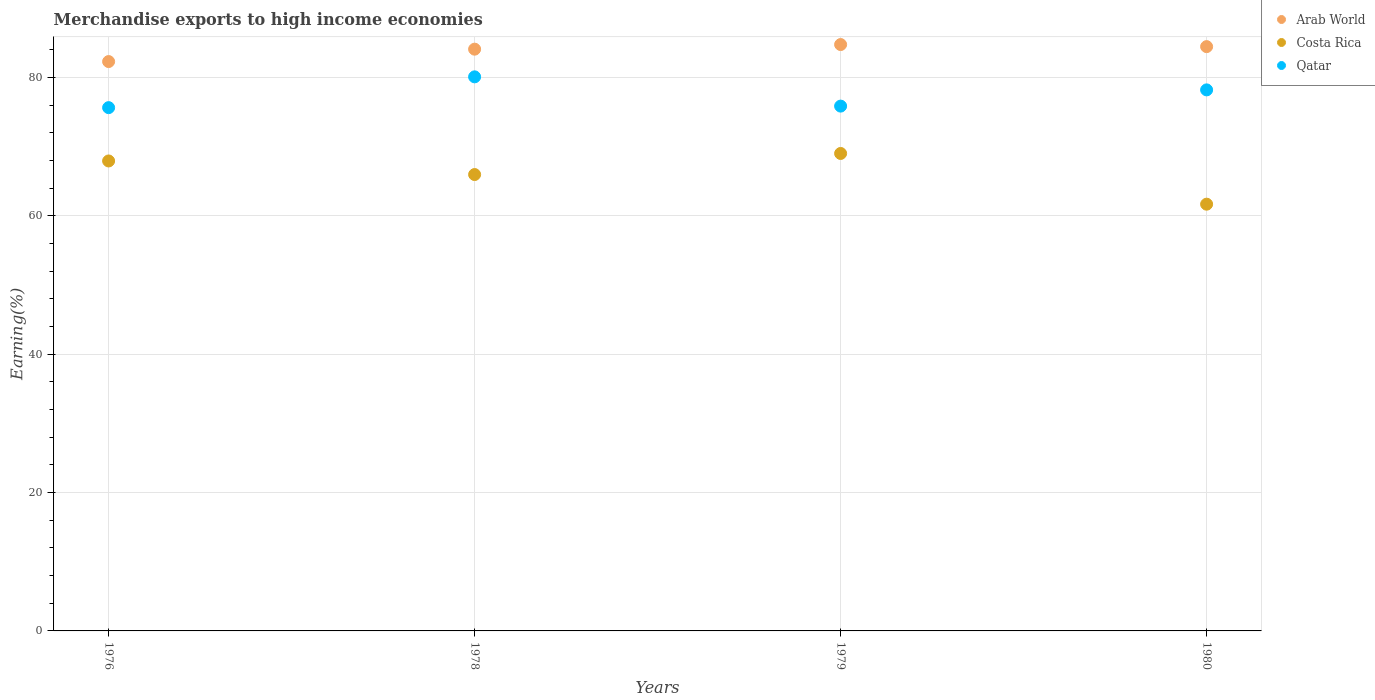What is the percentage of amount earned from merchandise exports in Qatar in 1978?
Ensure brevity in your answer.  80.09. Across all years, what is the maximum percentage of amount earned from merchandise exports in Arab World?
Your answer should be compact. 84.76. Across all years, what is the minimum percentage of amount earned from merchandise exports in Qatar?
Ensure brevity in your answer.  75.64. In which year was the percentage of amount earned from merchandise exports in Qatar maximum?
Your answer should be very brief. 1978. In which year was the percentage of amount earned from merchandise exports in Qatar minimum?
Give a very brief answer. 1976. What is the total percentage of amount earned from merchandise exports in Arab World in the graph?
Your answer should be compact. 335.62. What is the difference between the percentage of amount earned from merchandise exports in Arab World in 1978 and that in 1980?
Ensure brevity in your answer.  -0.37. What is the difference between the percentage of amount earned from merchandise exports in Costa Rica in 1978 and the percentage of amount earned from merchandise exports in Qatar in 1980?
Offer a very short reply. -12.24. What is the average percentage of amount earned from merchandise exports in Costa Rica per year?
Provide a succinct answer. 66.15. In the year 1979, what is the difference between the percentage of amount earned from merchandise exports in Costa Rica and percentage of amount earned from merchandise exports in Arab World?
Give a very brief answer. -15.74. What is the ratio of the percentage of amount earned from merchandise exports in Qatar in 1978 to that in 1979?
Offer a very short reply. 1.06. What is the difference between the highest and the second highest percentage of amount earned from merchandise exports in Qatar?
Offer a terse response. 1.89. What is the difference between the highest and the lowest percentage of amount earned from merchandise exports in Costa Rica?
Your response must be concise. 7.33. Is the percentage of amount earned from merchandise exports in Qatar strictly greater than the percentage of amount earned from merchandise exports in Arab World over the years?
Ensure brevity in your answer.  No. How many years are there in the graph?
Your answer should be compact. 4. Are the values on the major ticks of Y-axis written in scientific E-notation?
Ensure brevity in your answer.  No. Where does the legend appear in the graph?
Provide a succinct answer. Top right. What is the title of the graph?
Keep it short and to the point. Merchandise exports to high income economies. Does "Ireland" appear as one of the legend labels in the graph?
Provide a succinct answer. No. What is the label or title of the X-axis?
Your answer should be very brief. Years. What is the label or title of the Y-axis?
Your answer should be compact. Earning(%). What is the Earning(%) in Arab World in 1976?
Give a very brief answer. 82.3. What is the Earning(%) of Costa Rica in 1976?
Offer a very short reply. 67.94. What is the Earning(%) of Qatar in 1976?
Offer a very short reply. 75.64. What is the Earning(%) of Arab World in 1978?
Keep it short and to the point. 84.1. What is the Earning(%) of Costa Rica in 1978?
Your answer should be very brief. 65.97. What is the Earning(%) of Qatar in 1978?
Offer a terse response. 80.09. What is the Earning(%) of Arab World in 1979?
Your answer should be very brief. 84.76. What is the Earning(%) of Costa Rica in 1979?
Offer a terse response. 69.02. What is the Earning(%) in Qatar in 1979?
Make the answer very short. 75.86. What is the Earning(%) in Arab World in 1980?
Ensure brevity in your answer.  84.46. What is the Earning(%) in Costa Rica in 1980?
Make the answer very short. 61.69. What is the Earning(%) of Qatar in 1980?
Your answer should be very brief. 78.21. Across all years, what is the maximum Earning(%) of Arab World?
Give a very brief answer. 84.76. Across all years, what is the maximum Earning(%) of Costa Rica?
Offer a terse response. 69.02. Across all years, what is the maximum Earning(%) of Qatar?
Keep it short and to the point. 80.09. Across all years, what is the minimum Earning(%) in Arab World?
Your response must be concise. 82.3. Across all years, what is the minimum Earning(%) of Costa Rica?
Make the answer very short. 61.69. Across all years, what is the minimum Earning(%) of Qatar?
Ensure brevity in your answer.  75.64. What is the total Earning(%) of Arab World in the graph?
Provide a short and direct response. 335.62. What is the total Earning(%) in Costa Rica in the graph?
Provide a succinct answer. 264.61. What is the total Earning(%) in Qatar in the graph?
Offer a very short reply. 309.81. What is the difference between the Earning(%) of Arab World in 1976 and that in 1978?
Your response must be concise. -1.79. What is the difference between the Earning(%) of Costa Rica in 1976 and that in 1978?
Provide a short and direct response. 1.96. What is the difference between the Earning(%) of Qatar in 1976 and that in 1978?
Your response must be concise. -4.45. What is the difference between the Earning(%) of Arab World in 1976 and that in 1979?
Your response must be concise. -2.46. What is the difference between the Earning(%) in Costa Rica in 1976 and that in 1979?
Your answer should be compact. -1.08. What is the difference between the Earning(%) of Qatar in 1976 and that in 1979?
Keep it short and to the point. -0.22. What is the difference between the Earning(%) in Arab World in 1976 and that in 1980?
Offer a terse response. -2.16. What is the difference between the Earning(%) of Costa Rica in 1976 and that in 1980?
Make the answer very short. 6.25. What is the difference between the Earning(%) of Qatar in 1976 and that in 1980?
Offer a very short reply. -2.57. What is the difference between the Earning(%) of Arab World in 1978 and that in 1979?
Your answer should be very brief. -0.67. What is the difference between the Earning(%) of Costa Rica in 1978 and that in 1979?
Keep it short and to the point. -3.05. What is the difference between the Earning(%) of Qatar in 1978 and that in 1979?
Ensure brevity in your answer.  4.23. What is the difference between the Earning(%) of Arab World in 1978 and that in 1980?
Offer a very short reply. -0.37. What is the difference between the Earning(%) of Costa Rica in 1978 and that in 1980?
Provide a short and direct response. 4.28. What is the difference between the Earning(%) of Qatar in 1978 and that in 1980?
Keep it short and to the point. 1.89. What is the difference between the Earning(%) of Arab World in 1979 and that in 1980?
Your response must be concise. 0.3. What is the difference between the Earning(%) in Costa Rica in 1979 and that in 1980?
Your answer should be compact. 7.33. What is the difference between the Earning(%) of Qatar in 1979 and that in 1980?
Offer a terse response. -2.35. What is the difference between the Earning(%) of Arab World in 1976 and the Earning(%) of Costa Rica in 1978?
Offer a very short reply. 16.33. What is the difference between the Earning(%) in Arab World in 1976 and the Earning(%) in Qatar in 1978?
Give a very brief answer. 2.21. What is the difference between the Earning(%) in Costa Rica in 1976 and the Earning(%) in Qatar in 1978?
Make the answer very short. -12.16. What is the difference between the Earning(%) in Arab World in 1976 and the Earning(%) in Costa Rica in 1979?
Your answer should be compact. 13.28. What is the difference between the Earning(%) of Arab World in 1976 and the Earning(%) of Qatar in 1979?
Give a very brief answer. 6.44. What is the difference between the Earning(%) of Costa Rica in 1976 and the Earning(%) of Qatar in 1979?
Your answer should be very brief. -7.93. What is the difference between the Earning(%) of Arab World in 1976 and the Earning(%) of Costa Rica in 1980?
Offer a terse response. 20.62. What is the difference between the Earning(%) in Arab World in 1976 and the Earning(%) in Qatar in 1980?
Provide a short and direct response. 4.09. What is the difference between the Earning(%) in Costa Rica in 1976 and the Earning(%) in Qatar in 1980?
Your answer should be compact. -10.27. What is the difference between the Earning(%) of Arab World in 1978 and the Earning(%) of Costa Rica in 1979?
Provide a short and direct response. 15.08. What is the difference between the Earning(%) of Arab World in 1978 and the Earning(%) of Qatar in 1979?
Offer a very short reply. 8.23. What is the difference between the Earning(%) of Costa Rica in 1978 and the Earning(%) of Qatar in 1979?
Your answer should be compact. -9.89. What is the difference between the Earning(%) in Arab World in 1978 and the Earning(%) in Costa Rica in 1980?
Give a very brief answer. 22.41. What is the difference between the Earning(%) in Arab World in 1978 and the Earning(%) in Qatar in 1980?
Offer a very short reply. 5.89. What is the difference between the Earning(%) in Costa Rica in 1978 and the Earning(%) in Qatar in 1980?
Offer a terse response. -12.24. What is the difference between the Earning(%) in Arab World in 1979 and the Earning(%) in Costa Rica in 1980?
Offer a very short reply. 23.07. What is the difference between the Earning(%) in Arab World in 1979 and the Earning(%) in Qatar in 1980?
Ensure brevity in your answer.  6.55. What is the difference between the Earning(%) in Costa Rica in 1979 and the Earning(%) in Qatar in 1980?
Offer a terse response. -9.19. What is the average Earning(%) in Arab World per year?
Make the answer very short. 83.91. What is the average Earning(%) of Costa Rica per year?
Your response must be concise. 66.15. What is the average Earning(%) of Qatar per year?
Provide a succinct answer. 77.45. In the year 1976, what is the difference between the Earning(%) of Arab World and Earning(%) of Costa Rica?
Offer a terse response. 14.37. In the year 1976, what is the difference between the Earning(%) of Arab World and Earning(%) of Qatar?
Ensure brevity in your answer.  6.66. In the year 1976, what is the difference between the Earning(%) in Costa Rica and Earning(%) in Qatar?
Your response must be concise. -7.71. In the year 1978, what is the difference between the Earning(%) of Arab World and Earning(%) of Costa Rica?
Offer a very short reply. 18.12. In the year 1978, what is the difference between the Earning(%) of Arab World and Earning(%) of Qatar?
Offer a terse response. 4. In the year 1978, what is the difference between the Earning(%) of Costa Rica and Earning(%) of Qatar?
Your answer should be compact. -14.12. In the year 1979, what is the difference between the Earning(%) of Arab World and Earning(%) of Costa Rica?
Provide a succinct answer. 15.74. In the year 1979, what is the difference between the Earning(%) of Arab World and Earning(%) of Qatar?
Offer a terse response. 8.9. In the year 1979, what is the difference between the Earning(%) of Costa Rica and Earning(%) of Qatar?
Offer a very short reply. -6.84. In the year 1980, what is the difference between the Earning(%) of Arab World and Earning(%) of Costa Rica?
Make the answer very short. 22.78. In the year 1980, what is the difference between the Earning(%) in Arab World and Earning(%) in Qatar?
Provide a succinct answer. 6.25. In the year 1980, what is the difference between the Earning(%) of Costa Rica and Earning(%) of Qatar?
Make the answer very short. -16.52. What is the ratio of the Earning(%) in Arab World in 1976 to that in 1978?
Your response must be concise. 0.98. What is the ratio of the Earning(%) in Costa Rica in 1976 to that in 1978?
Ensure brevity in your answer.  1.03. What is the ratio of the Earning(%) of Qatar in 1976 to that in 1978?
Give a very brief answer. 0.94. What is the ratio of the Earning(%) in Costa Rica in 1976 to that in 1979?
Your answer should be compact. 0.98. What is the ratio of the Earning(%) in Arab World in 1976 to that in 1980?
Provide a succinct answer. 0.97. What is the ratio of the Earning(%) in Costa Rica in 1976 to that in 1980?
Offer a terse response. 1.1. What is the ratio of the Earning(%) in Qatar in 1976 to that in 1980?
Offer a terse response. 0.97. What is the ratio of the Earning(%) of Arab World in 1978 to that in 1979?
Your response must be concise. 0.99. What is the ratio of the Earning(%) of Costa Rica in 1978 to that in 1979?
Provide a succinct answer. 0.96. What is the ratio of the Earning(%) in Qatar in 1978 to that in 1979?
Your answer should be compact. 1.06. What is the ratio of the Earning(%) of Arab World in 1978 to that in 1980?
Your answer should be very brief. 1. What is the ratio of the Earning(%) of Costa Rica in 1978 to that in 1980?
Provide a succinct answer. 1.07. What is the ratio of the Earning(%) in Qatar in 1978 to that in 1980?
Offer a very short reply. 1.02. What is the ratio of the Earning(%) in Arab World in 1979 to that in 1980?
Your response must be concise. 1. What is the ratio of the Earning(%) in Costa Rica in 1979 to that in 1980?
Make the answer very short. 1.12. What is the ratio of the Earning(%) in Qatar in 1979 to that in 1980?
Provide a succinct answer. 0.97. What is the difference between the highest and the second highest Earning(%) of Arab World?
Make the answer very short. 0.3. What is the difference between the highest and the second highest Earning(%) of Costa Rica?
Offer a very short reply. 1.08. What is the difference between the highest and the second highest Earning(%) in Qatar?
Offer a very short reply. 1.89. What is the difference between the highest and the lowest Earning(%) in Arab World?
Your answer should be compact. 2.46. What is the difference between the highest and the lowest Earning(%) of Costa Rica?
Give a very brief answer. 7.33. What is the difference between the highest and the lowest Earning(%) of Qatar?
Your answer should be compact. 4.45. 